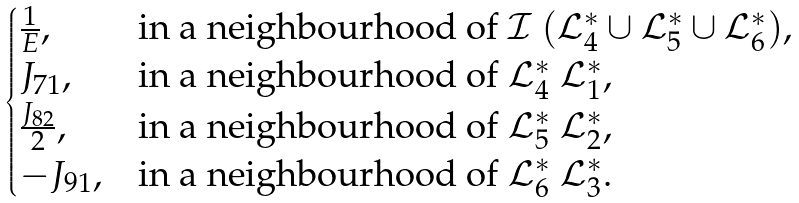<formula> <loc_0><loc_0><loc_500><loc_500>\begin{cases} \frac { 1 } { E } , & \text {in a neighbourhood of} \ \mathcal { I } \ ( \mathcal { L } _ { 4 } ^ { * } \cup \mathcal { L } _ { 5 } ^ { * } \cup \mathcal { L } _ { 6 } ^ { * } ) , \\ J _ { 7 1 } , & \text {in a neighbourhood of} \ \mathcal { L } _ { 4 } ^ { * } \ \mathcal { L } _ { 1 } ^ { * } , \\ \frac { J _ { 8 2 } } { 2 } , & \text {in a neighbourhood of} \ \mathcal { L } _ { 5 } ^ { * } \ \mathcal { L } _ { 2 } ^ { * } , \\ - J _ { 9 1 } , & \text {in a neighbourhood of} \ \mathcal { L } _ { 6 } ^ { * } \ \mathcal { L } _ { 3 } ^ { * } . \end{cases}</formula> 